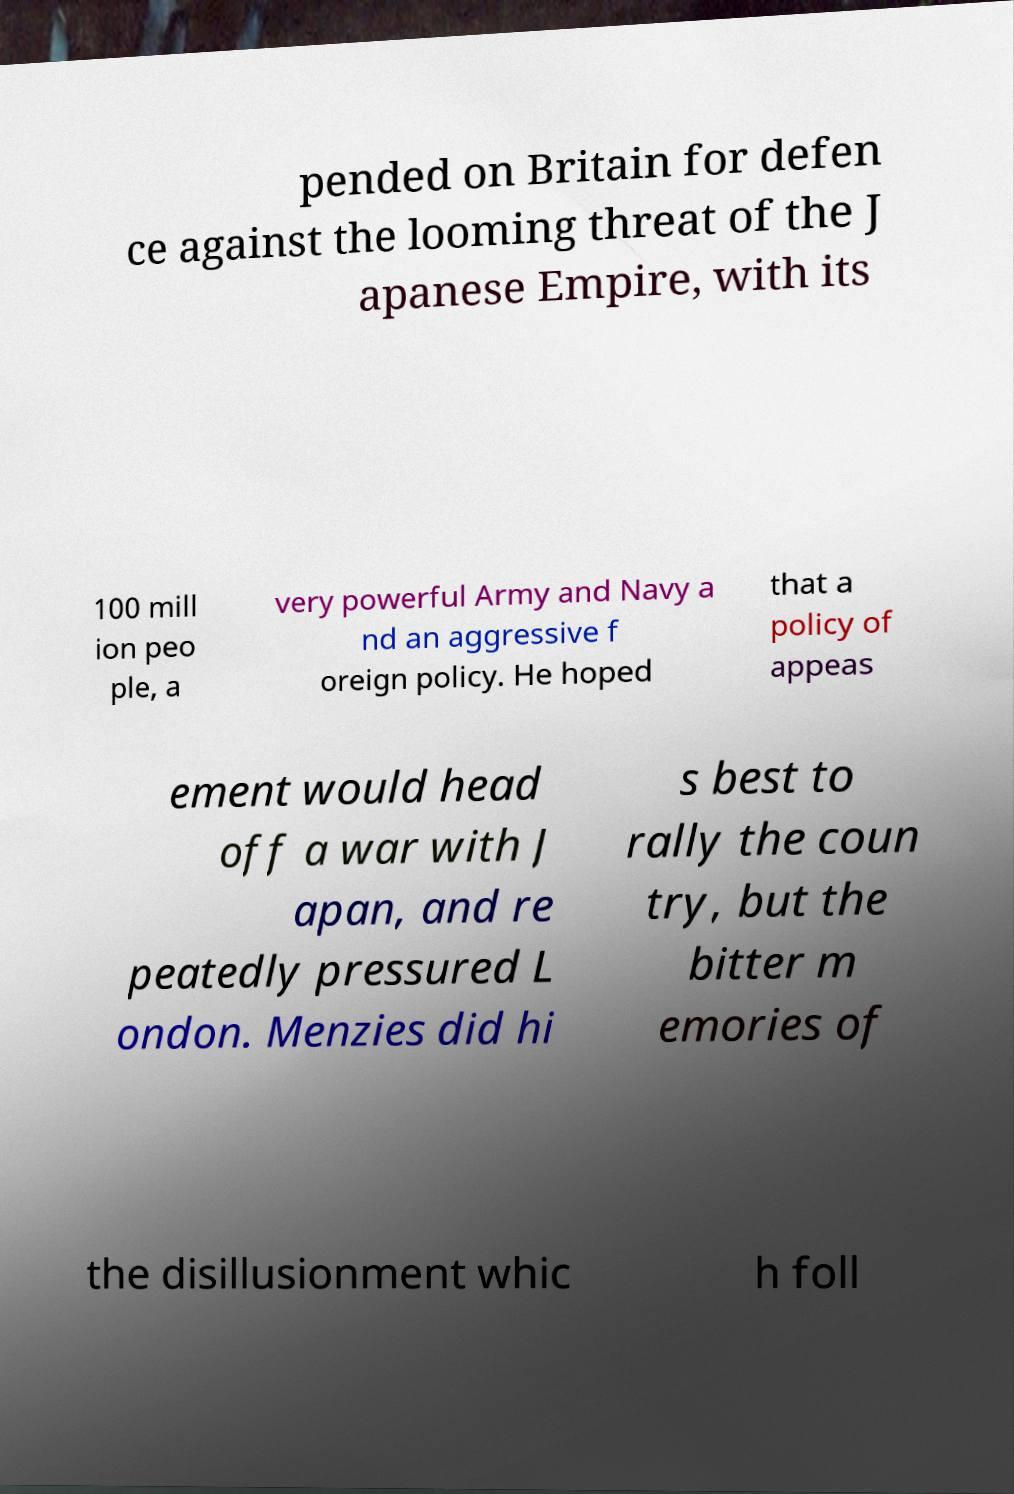Please identify and transcribe the text found in this image. pended on Britain for defen ce against the looming threat of the J apanese Empire, with its 100 mill ion peo ple, a very powerful Army and Navy a nd an aggressive f oreign policy. He hoped that a policy of appeas ement would head off a war with J apan, and re peatedly pressured L ondon. Menzies did hi s best to rally the coun try, but the bitter m emories of the disillusionment whic h foll 